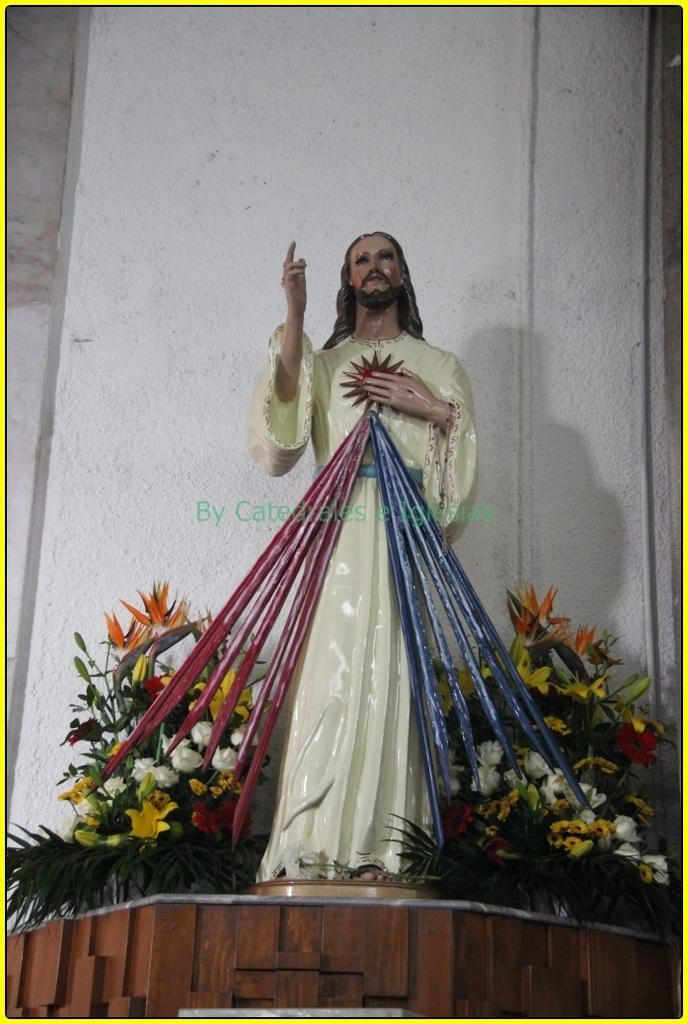What is the main subject in the middle of the image? There is a statue in the middle of the image. What can be seen at the bottom of the image? There are plants and flowers at the bottom of the image. What is visible in the background of the image? There is a wall in the background of the image. What type of power is being discussed by the statue in the image? There is no discussion or power mentioned in the image; it features a statue, plants, flowers, and a wall. Can you see a shoe on the statue in the image? There is no shoe present on the statue in the image. 